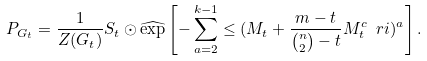Convert formula to latex. <formula><loc_0><loc_0><loc_500><loc_500>P _ { G _ { t } } = \frac { 1 } { Z ( G _ { t } ) } S _ { t } \odot \widehat { \exp } \left [ - \sum _ { a = 2 } ^ { k - 1 } \leq ( M _ { t } + \frac { m - t } { { n \choose 2 } - t } M _ { t } ^ { c } \ r i ) ^ { a } \right ] .</formula> 